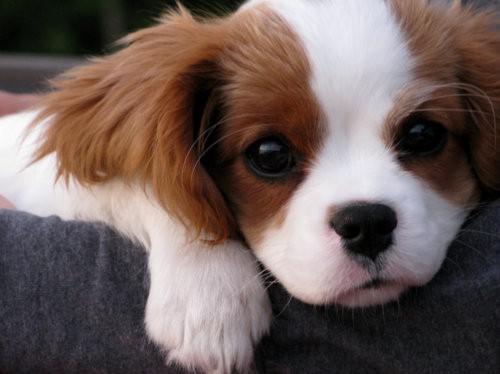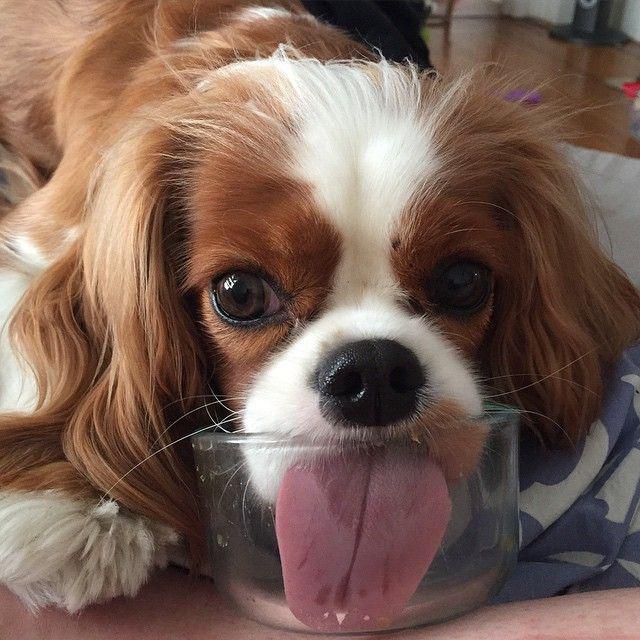The first image is the image on the left, the second image is the image on the right. Assess this claim about the two images: "The right image contains more dogs than the left image.". Correct or not? Answer yes or no. No. 